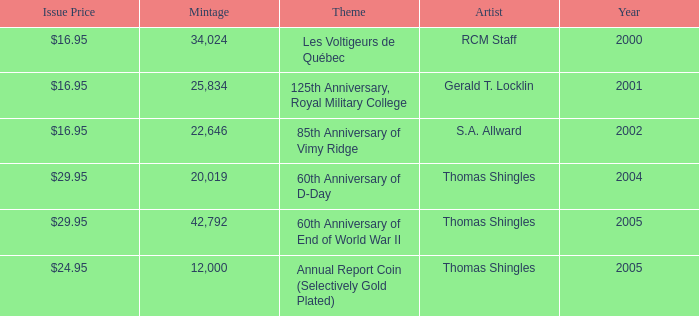What year was S.A. Allward's theme that had an issue price of $16.95 released? 2002.0. 